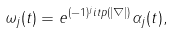Convert formula to latex. <formula><loc_0><loc_0><loc_500><loc_500>\omega _ { j } ( t ) = e ^ { ( - 1 ) ^ { j } i t p ( | \nabla | ) } \alpha _ { j } ( t ) ,</formula> 